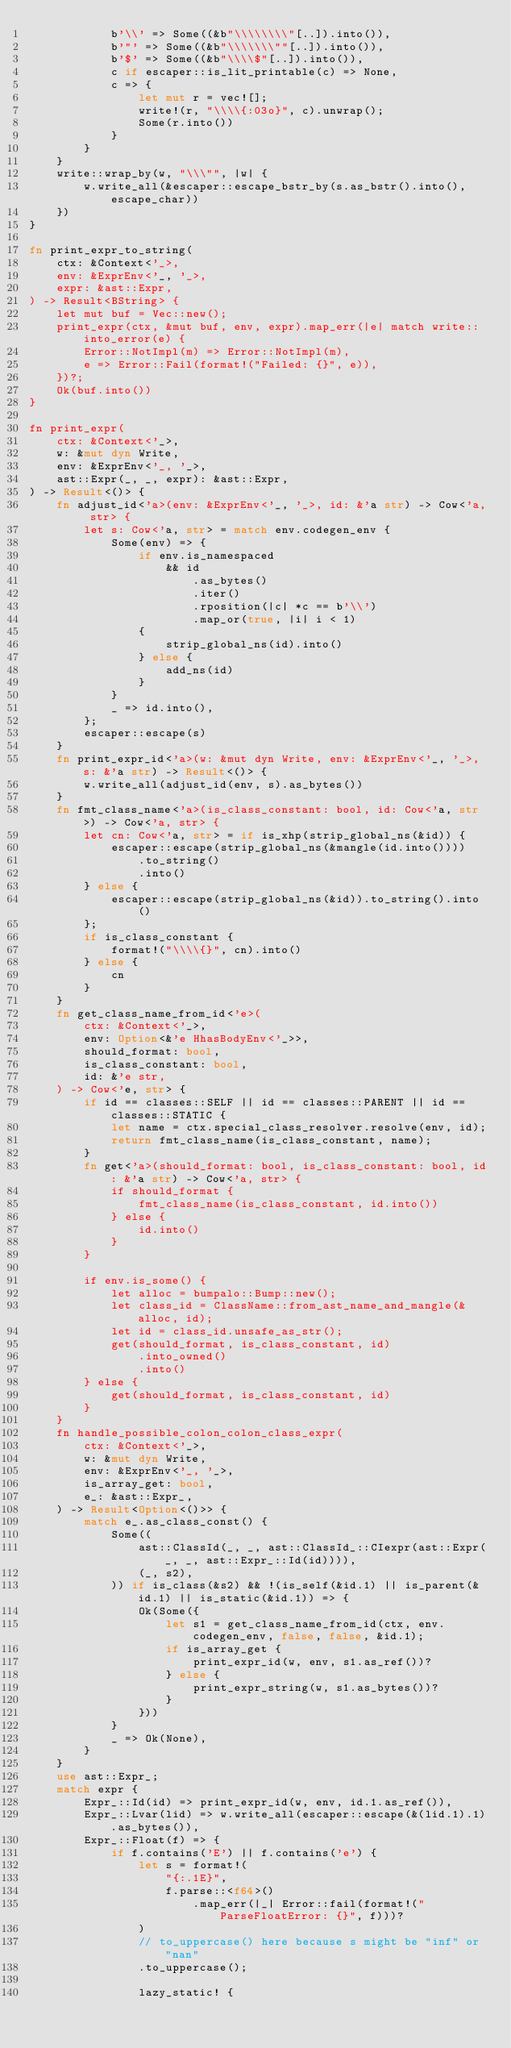Convert code to text. <code><loc_0><loc_0><loc_500><loc_500><_Rust_>            b'\\' => Some((&b"\\\\\\\\"[..]).into()),
            b'"' => Some((&b"\\\\\\\""[..]).into()),
            b'$' => Some((&b"\\\\$"[..]).into()),
            c if escaper::is_lit_printable(c) => None,
            c => {
                let mut r = vec![];
                write!(r, "\\\\{:03o}", c).unwrap();
                Some(r.into())
            }
        }
    }
    write::wrap_by(w, "\\\"", |w| {
        w.write_all(&escaper::escape_bstr_by(s.as_bstr().into(), escape_char))
    })
}

fn print_expr_to_string(
    ctx: &Context<'_>,
    env: &ExprEnv<'_, '_>,
    expr: &ast::Expr,
) -> Result<BString> {
    let mut buf = Vec::new();
    print_expr(ctx, &mut buf, env, expr).map_err(|e| match write::into_error(e) {
        Error::NotImpl(m) => Error::NotImpl(m),
        e => Error::Fail(format!("Failed: {}", e)),
    })?;
    Ok(buf.into())
}

fn print_expr(
    ctx: &Context<'_>,
    w: &mut dyn Write,
    env: &ExprEnv<'_, '_>,
    ast::Expr(_, _, expr): &ast::Expr,
) -> Result<()> {
    fn adjust_id<'a>(env: &ExprEnv<'_, '_>, id: &'a str) -> Cow<'a, str> {
        let s: Cow<'a, str> = match env.codegen_env {
            Some(env) => {
                if env.is_namespaced
                    && id
                        .as_bytes()
                        .iter()
                        .rposition(|c| *c == b'\\')
                        .map_or(true, |i| i < 1)
                {
                    strip_global_ns(id).into()
                } else {
                    add_ns(id)
                }
            }
            _ => id.into(),
        };
        escaper::escape(s)
    }
    fn print_expr_id<'a>(w: &mut dyn Write, env: &ExprEnv<'_, '_>, s: &'a str) -> Result<()> {
        w.write_all(adjust_id(env, s).as_bytes())
    }
    fn fmt_class_name<'a>(is_class_constant: bool, id: Cow<'a, str>) -> Cow<'a, str> {
        let cn: Cow<'a, str> = if is_xhp(strip_global_ns(&id)) {
            escaper::escape(strip_global_ns(&mangle(id.into())))
                .to_string()
                .into()
        } else {
            escaper::escape(strip_global_ns(&id)).to_string().into()
        };
        if is_class_constant {
            format!("\\\\{}", cn).into()
        } else {
            cn
        }
    }
    fn get_class_name_from_id<'e>(
        ctx: &Context<'_>,
        env: Option<&'e HhasBodyEnv<'_>>,
        should_format: bool,
        is_class_constant: bool,
        id: &'e str,
    ) -> Cow<'e, str> {
        if id == classes::SELF || id == classes::PARENT || id == classes::STATIC {
            let name = ctx.special_class_resolver.resolve(env, id);
            return fmt_class_name(is_class_constant, name);
        }
        fn get<'a>(should_format: bool, is_class_constant: bool, id: &'a str) -> Cow<'a, str> {
            if should_format {
                fmt_class_name(is_class_constant, id.into())
            } else {
                id.into()
            }
        }

        if env.is_some() {
            let alloc = bumpalo::Bump::new();
            let class_id = ClassName::from_ast_name_and_mangle(&alloc, id);
            let id = class_id.unsafe_as_str();
            get(should_format, is_class_constant, id)
                .into_owned()
                .into()
        } else {
            get(should_format, is_class_constant, id)
        }
    }
    fn handle_possible_colon_colon_class_expr(
        ctx: &Context<'_>,
        w: &mut dyn Write,
        env: &ExprEnv<'_, '_>,
        is_array_get: bool,
        e_: &ast::Expr_,
    ) -> Result<Option<()>> {
        match e_.as_class_const() {
            Some((
                ast::ClassId(_, _, ast::ClassId_::CIexpr(ast::Expr(_, _, ast::Expr_::Id(id)))),
                (_, s2),
            )) if is_class(&s2) && !(is_self(&id.1) || is_parent(&id.1) || is_static(&id.1)) => {
                Ok(Some({
                    let s1 = get_class_name_from_id(ctx, env.codegen_env, false, false, &id.1);
                    if is_array_get {
                        print_expr_id(w, env, s1.as_ref())?
                    } else {
                        print_expr_string(w, s1.as_bytes())?
                    }
                }))
            }
            _ => Ok(None),
        }
    }
    use ast::Expr_;
    match expr {
        Expr_::Id(id) => print_expr_id(w, env, id.1.as_ref()),
        Expr_::Lvar(lid) => w.write_all(escaper::escape(&(lid.1).1).as_bytes()),
        Expr_::Float(f) => {
            if f.contains('E') || f.contains('e') {
                let s = format!(
                    "{:.1E}",
                    f.parse::<f64>()
                        .map_err(|_| Error::fail(format!("ParseFloatError: {}", f)))?
                )
                // to_uppercase() here because s might be "inf" or "nan"
                .to_uppercase();

                lazy_static! {</code> 